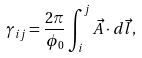<formula> <loc_0><loc_0><loc_500><loc_500>\gamma _ { i j } = \frac { 2 \pi } { \phi _ { 0 } } \int _ { i } ^ { j } \vec { A } \cdot d \vec { l } ,</formula> 